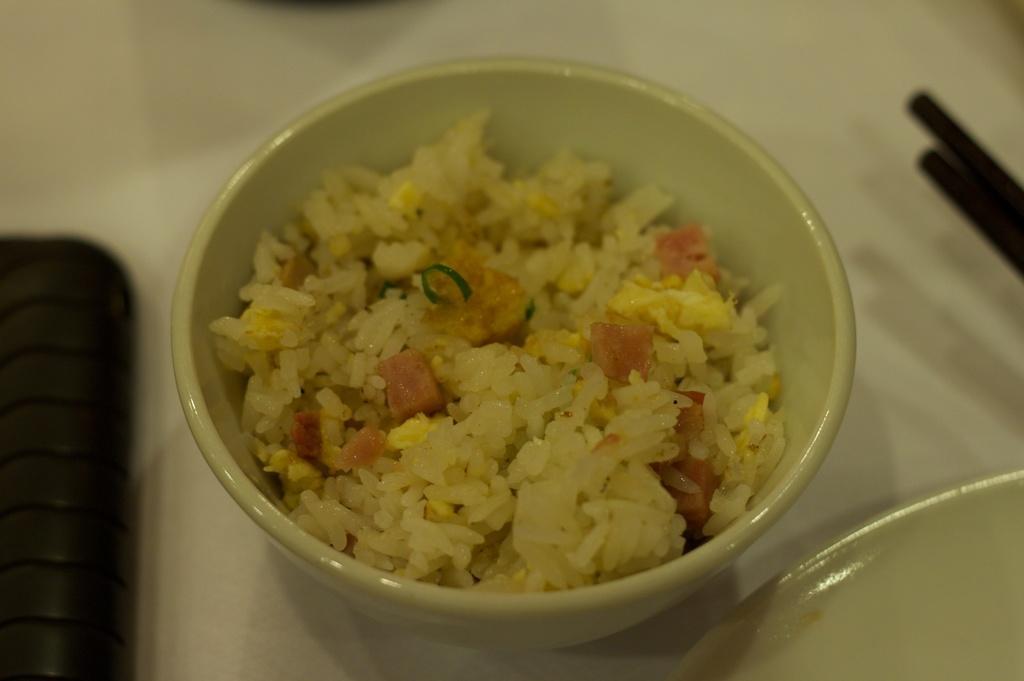Could you give a brief overview of what you see in this image? In this image I can see the bowl with food. The food is colorful and the bowl is in cream color. To the side of the bowl I can see the black color object and another plate. These are on the white color surface. 